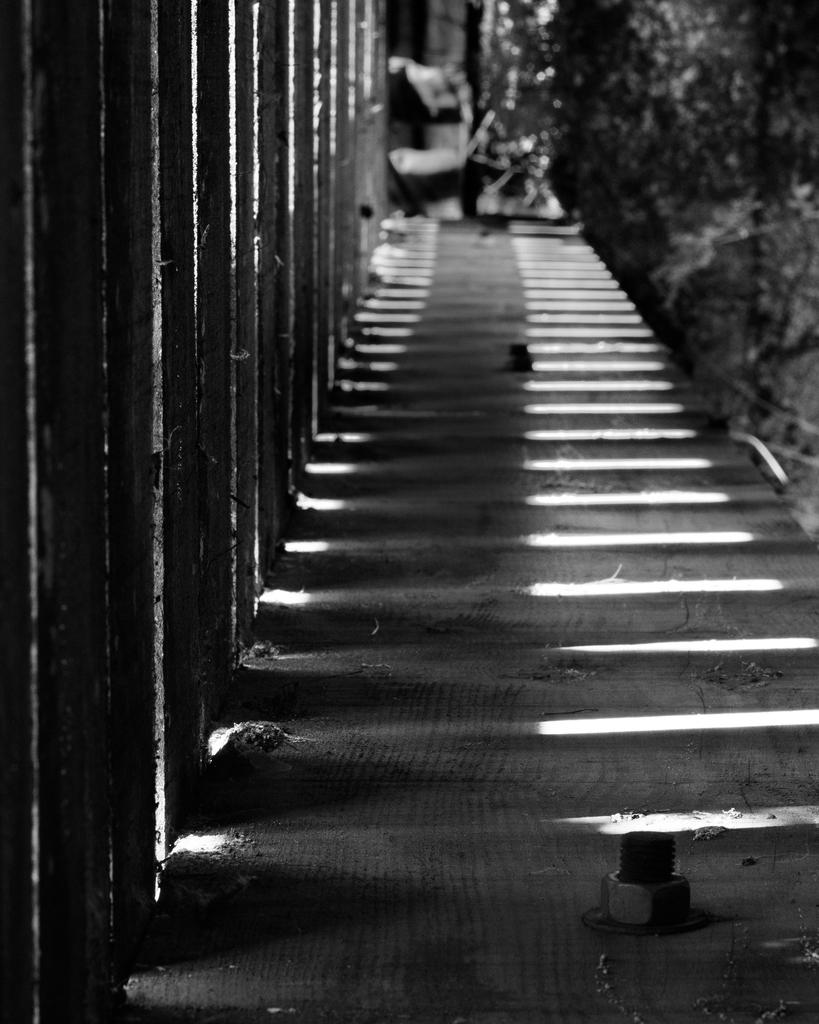What is the color scheme of the image? The image is black and white. What can be seen in the image besides the color scheme? There are stairs in the image. What feature is present on the left side of the stairs? There is a railing on the left side of the stairs. What type of vegetation is on the right side of the stairs? There are plants on the right side of the stairs. What type of judge is depicted in the image? There is no judge present in the image; it features stairs with a railing and plants. What shape is the church in the image? There is no church present in the image; it features stairs with a railing and plants. 